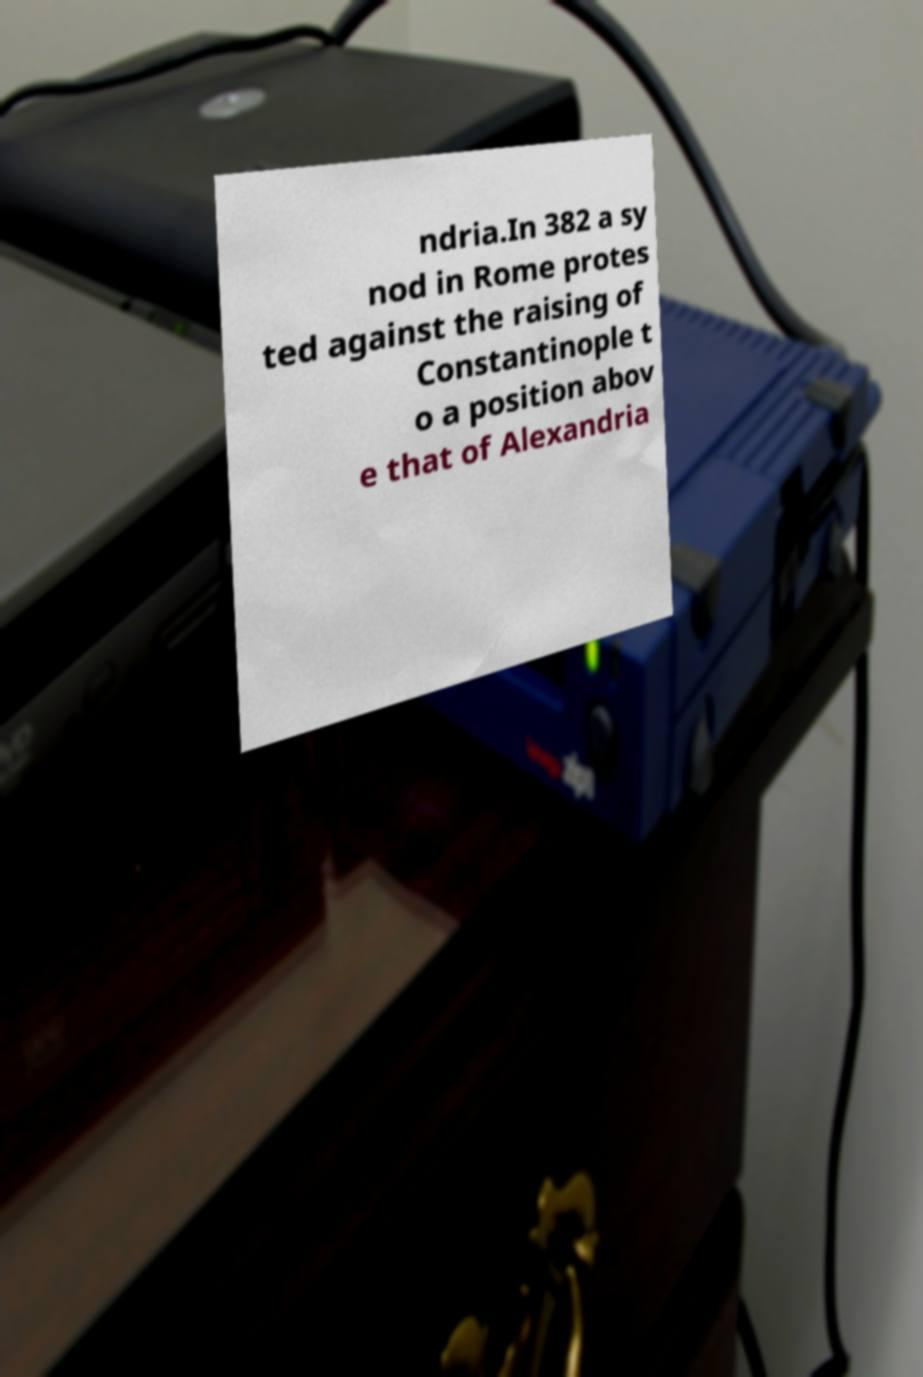What messages or text are displayed in this image? I need them in a readable, typed format. ndria.In 382 a sy nod in Rome protes ted against the raising of Constantinople t o a position abov e that of Alexandria 